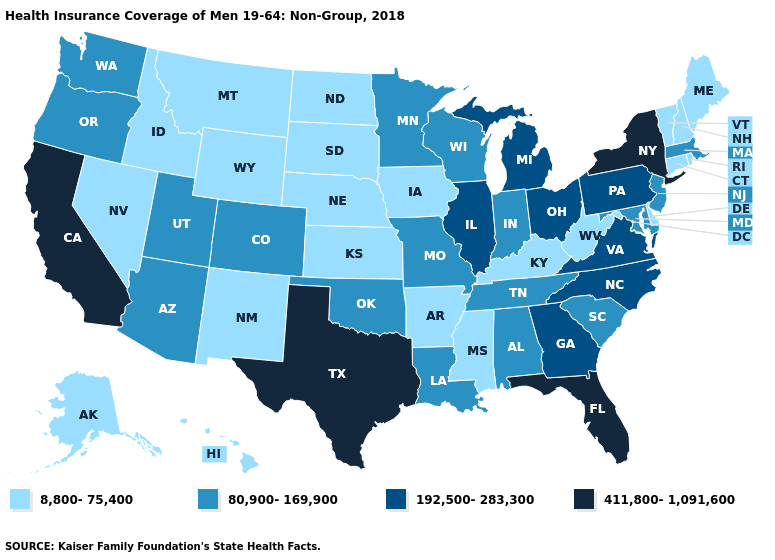Name the states that have a value in the range 8,800-75,400?
Concise answer only. Alaska, Arkansas, Connecticut, Delaware, Hawaii, Idaho, Iowa, Kansas, Kentucky, Maine, Mississippi, Montana, Nebraska, Nevada, New Hampshire, New Mexico, North Dakota, Rhode Island, South Dakota, Vermont, West Virginia, Wyoming. What is the highest value in the USA?
Short answer required. 411,800-1,091,600. Name the states that have a value in the range 192,500-283,300?
Give a very brief answer. Georgia, Illinois, Michigan, North Carolina, Ohio, Pennsylvania, Virginia. Does Kentucky have the same value as Oklahoma?
Keep it brief. No. What is the value of Montana?
Write a very short answer. 8,800-75,400. What is the value of Alabama?
Short answer required. 80,900-169,900. Name the states that have a value in the range 8,800-75,400?
Short answer required. Alaska, Arkansas, Connecticut, Delaware, Hawaii, Idaho, Iowa, Kansas, Kentucky, Maine, Mississippi, Montana, Nebraska, Nevada, New Hampshire, New Mexico, North Dakota, Rhode Island, South Dakota, Vermont, West Virginia, Wyoming. What is the value of Washington?
Quick response, please. 80,900-169,900. Does California have the highest value in the USA?
Answer briefly. Yes. What is the value of Nevada?
Answer briefly. 8,800-75,400. Which states have the highest value in the USA?
Write a very short answer. California, Florida, New York, Texas. Name the states that have a value in the range 192,500-283,300?
Keep it brief. Georgia, Illinois, Michigan, North Carolina, Ohio, Pennsylvania, Virginia. Does Wyoming have the lowest value in the West?
Write a very short answer. Yes. What is the value of Kansas?
Concise answer only. 8,800-75,400. What is the highest value in states that border Oregon?
Keep it brief. 411,800-1,091,600. 